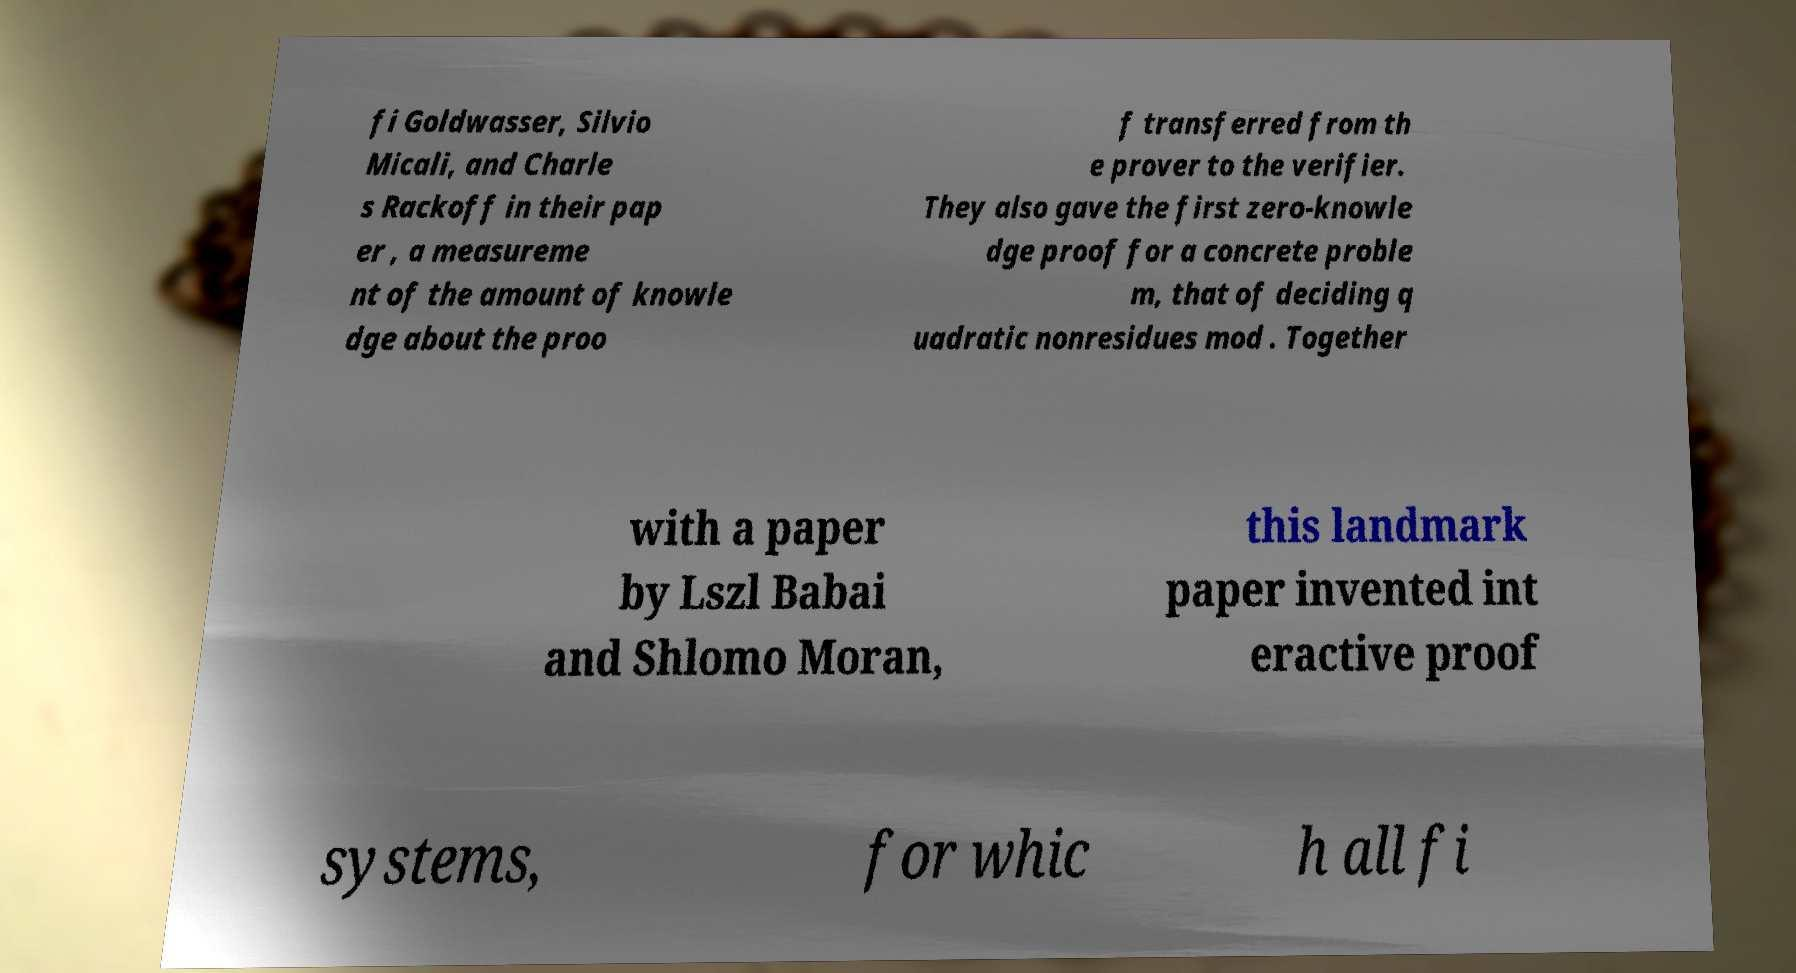Could you assist in decoding the text presented in this image and type it out clearly? fi Goldwasser, Silvio Micali, and Charle s Rackoff in their pap er , a measureme nt of the amount of knowle dge about the proo f transferred from th e prover to the verifier. They also gave the first zero-knowle dge proof for a concrete proble m, that of deciding q uadratic nonresidues mod . Together with a paper by Lszl Babai and Shlomo Moran, this landmark paper invented int eractive proof systems, for whic h all fi 